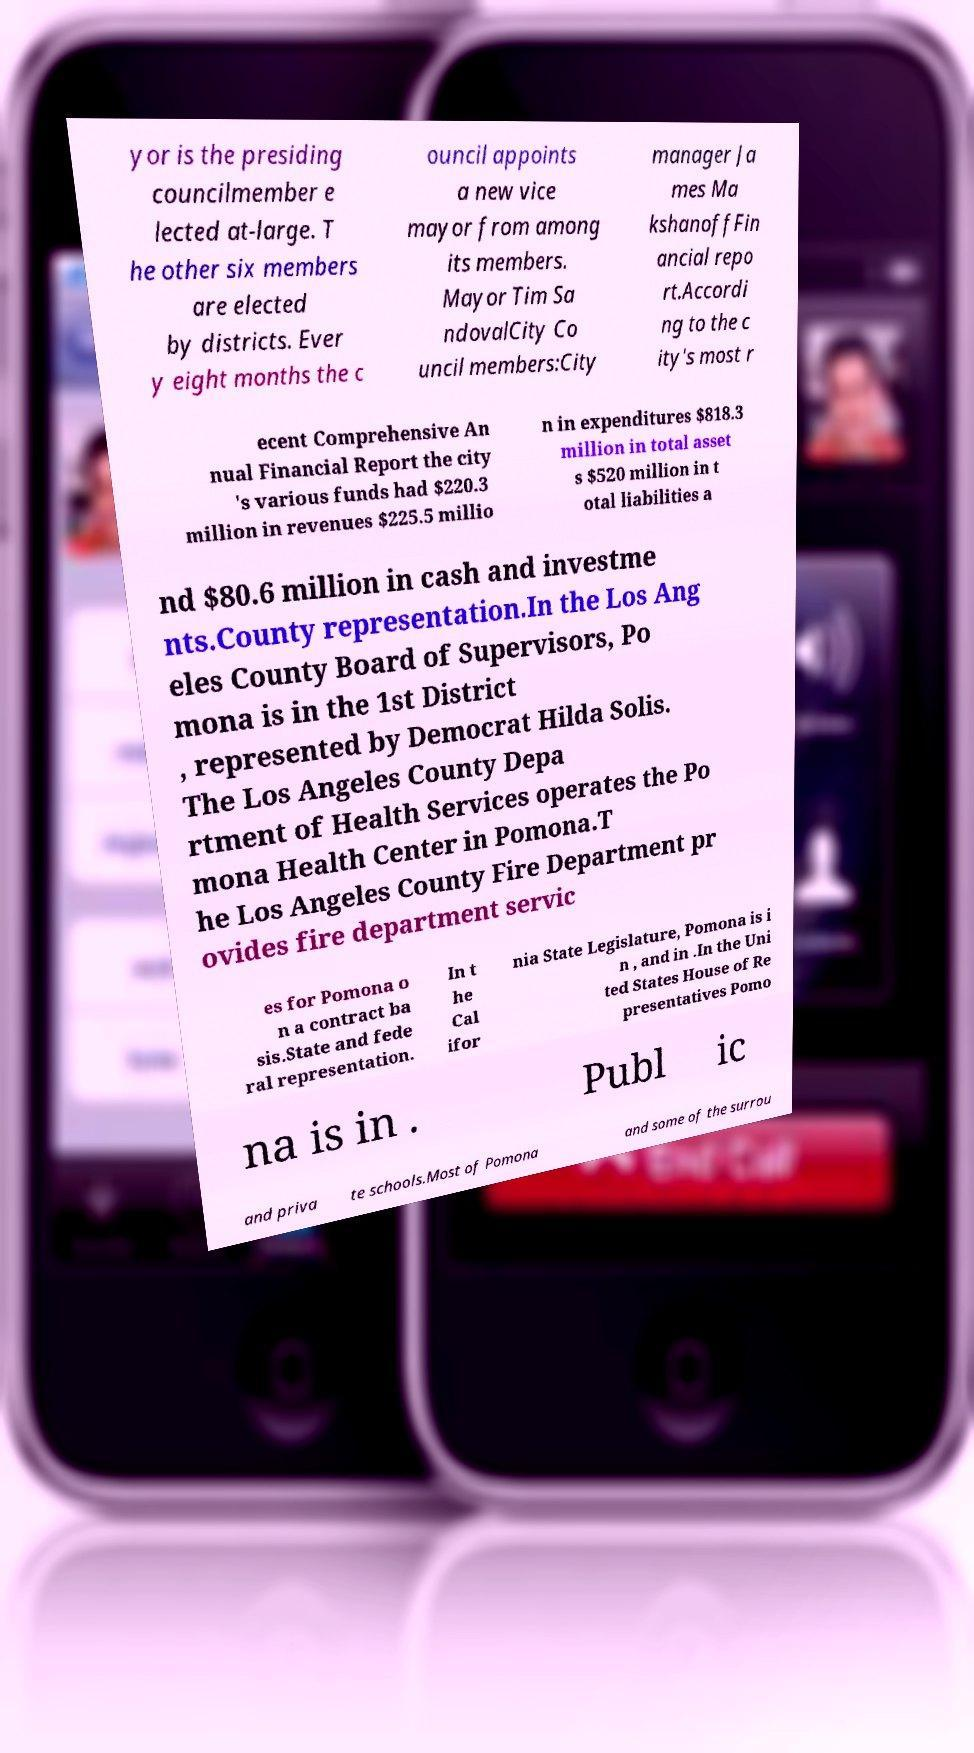Can you read and provide the text displayed in the image?This photo seems to have some interesting text. Can you extract and type it out for me? yor is the presiding councilmember e lected at-large. T he other six members are elected by districts. Ever y eight months the c ouncil appoints a new vice mayor from among its members. Mayor Tim Sa ndovalCity Co uncil members:City manager Ja mes Ma kshanoffFin ancial repo rt.Accordi ng to the c ity's most r ecent Comprehensive An nual Financial Report the city 's various funds had $220.3 million in revenues $225.5 millio n in expenditures $818.3 million in total asset s $520 million in t otal liabilities a nd $80.6 million in cash and investme nts.County representation.In the Los Ang eles County Board of Supervisors, Po mona is in the 1st District , represented by Democrat Hilda Solis. The Los Angeles County Depa rtment of Health Services operates the Po mona Health Center in Pomona.T he Los Angeles County Fire Department pr ovides fire department servic es for Pomona o n a contract ba sis.State and fede ral representation. In t he Cal ifor nia State Legislature, Pomona is i n , and in .In the Uni ted States House of Re presentatives Pomo na is in . Publ ic and priva te schools.Most of Pomona and some of the surrou 